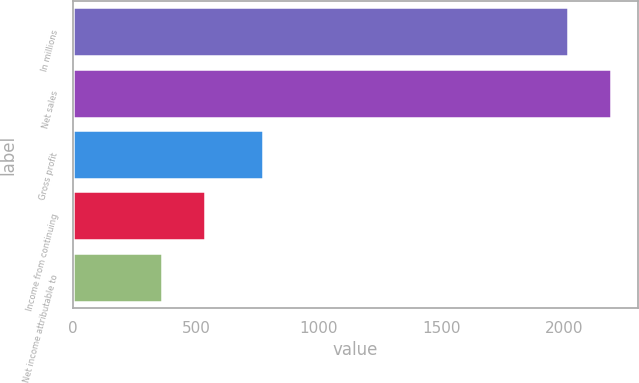<chart> <loc_0><loc_0><loc_500><loc_500><bar_chart><fcel>In millions<fcel>Net sales<fcel>Gross profit<fcel>Income from continuing<fcel>Net income attributable to<nl><fcel>2014<fcel>2191.8<fcel>772<fcel>537.8<fcel>360<nl></chart> 